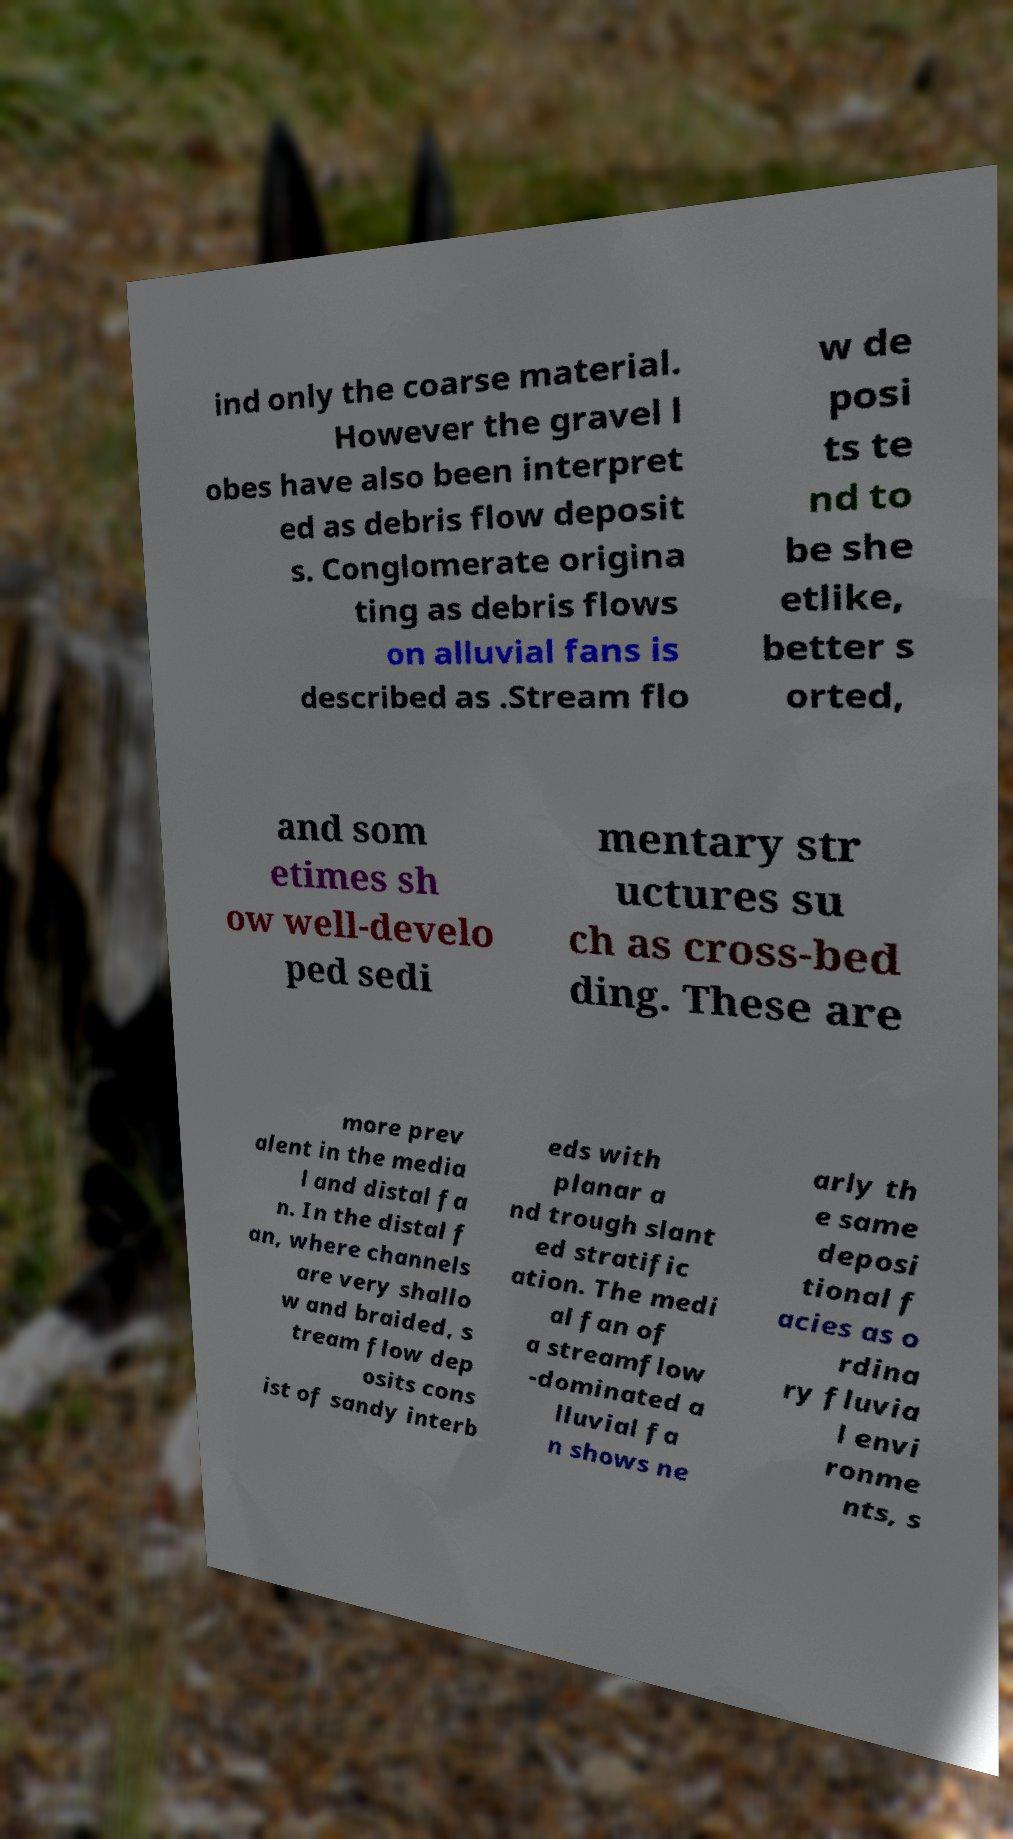For documentation purposes, I need the text within this image transcribed. Could you provide that? ind only the coarse material. However the gravel l obes have also been interpret ed as debris flow deposit s. Conglomerate origina ting as debris flows on alluvial fans is described as .Stream flo w de posi ts te nd to be she etlike, better s orted, and som etimes sh ow well-develo ped sedi mentary str uctures su ch as cross-bed ding. These are more prev alent in the media l and distal fa n. In the distal f an, where channels are very shallo w and braided, s tream flow dep osits cons ist of sandy interb eds with planar a nd trough slant ed stratific ation. The medi al fan of a streamflow -dominated a lluvial fa n shows ne arly th e same deposi tional f acies as o rdina ry fluvia l envi ronme nts, s 